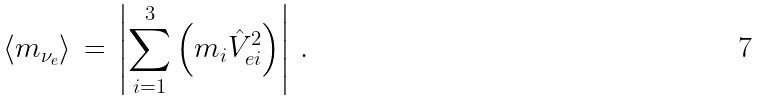<formula> <loc_0><loc_0><loc_500><loc_500>\langle m _ { \nu _ { e } } \rangle \, = \, \left | \sum _ { i = 1 } ^ { 3 } \left ( m _ { i } \hat { V } _ { e i } ^ { 2 } \right ) \right | \, .</formula> 